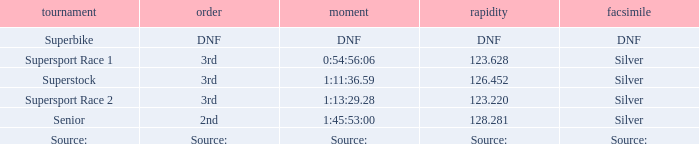Which race has a position of 3rd and a speed of 123.628? Supersport Race 1. Can you give me this table as a dict? {'header': ['tournament', 'order', 'moment', 'rapidity', 'facsimile'], 'rows': [['Superbike', 'DNF', 'DNF', 'DNF', 'DNF'], ['Supersport Race 1', '3rd', '0:54:56:06', '123.628', 'Silver'], ['Superstock', '3rd', '1:11:36.59', '126.452', 'Silver'], ['Supersport Race 2', '3rd', '1:13:29.28', '123.220', 'Silver'], ['Senior', '2nd', '1:45:53:00', '128.281', 'Silver'], ['Source:', 'Source:', 'Source:', 'Source:', 'Source:']]} 